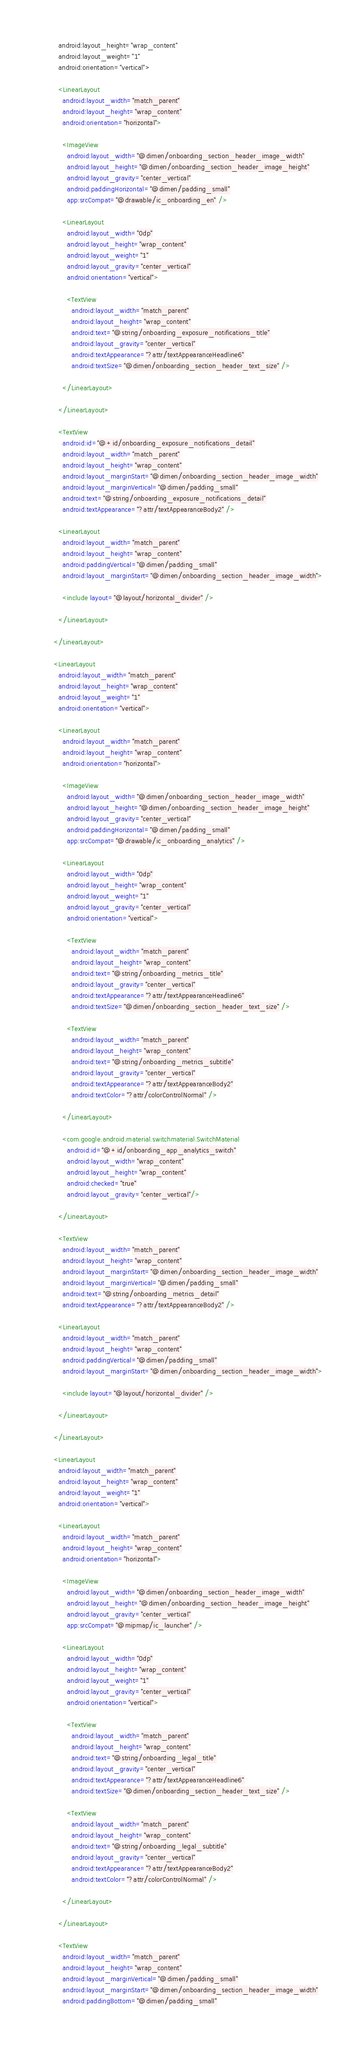Convert code to text. <code><loc_0><loc_0><loc_500><loc_500><_XML_>        android:layout_height="wrap_content"
        android:layout_weight="1"
        android:orientation="vertical">

        <LinearLayout
          android:layout_width="match_parent"
          android:layout_height="wrap_content"
          android:orientation="horizontal">

          <ImageView
            android:layout_width="@dimen/onboarding_section_header_image_width"
            android:layout_height="@dimen/onboarding_section_header_image_height"
            android:layout_gravity="center_vertical"
            android:paddingHorizontal="@dimen/padding_small"
            app:srcCompat="@drawable/ic_onboarding_en" />

          <LinearLayout
            android:layout_width="0dp"
            android:layout_height="wrap_content"
            android:layout_weight="1"
            android:layout_gravity="center_vertical"
            android:orientation="vertical">

            <TextView
              android:layout_width="match_parent"
              android:layout_height="wrap_content"
              android:text="@string/onboarding_exposure_notifications_title"
              android:layout_gravity="center_vertical"
              android:textAppearance="?attr/textAppearanceHeadline6"
              android:textSize="@dimen/onboarding_section_header_text_size" />

          </LinearLayout>

        </LinearLayout>

        <TextView
          android:id="@+id/onboarding_exposure_notifications_detail"
          android:layout_width="match_parent"
          android:layout_height="wrap_content"
          android:layout_marginStart="@dimen/onboarding_section_header_image_width"
          android:layout_marginVertical="@dimen/padding_small"
          android:text="@string/onboarding_exposure_notifications_detail"
          android:textAppearance="?attr/textAppearanceBody2" />

        <LinearLayout
          android:layout_width="match_parent"
          android:layout_height="wrap_content"
          android:paddingVertical="@dimen/padding_small"
          android:layout_marginStart="@dimen/onboarding_section_header_image_width">

          <include layout="@layout/horizontal_divider" />

        </LinearLayout>

      </LinearLayout>

      <LinearLayout
        android:layout_width="match_parent"
        android:layout_height="wrap_content"
        android:layout_weight="1"
        android:orientation="vertical">

        <LinearLayout
          android:layout_width="match_parent"
          android:layout_height="wrap_content"
          android:orientation="horizontal">

          <ImageView
            android:layout_width="@dimen/onboarding_section_header_image_width"
            android:layout_height="@dimen/onboarding_section_header_image_height"
            android:layout_gravity="center_vertical"
            android:paddingHorizontal="@dimen/padding_small"
            app:srcCompat="@drawable/ic_onboarding_analytics" />

          <LinearLayout
            android:layout_width="0dp"
            android:layout_height="wrap_content"
            android:layout_weight="1"
            android:layout_gravity="center_vertical"
            android:orientation="vertical">

            <TextView
              android:layout_width="match_parent"
              android:layout_height="wrap_content"
              android:text="@string/onboarding_metrics_title"
              android:layout_gravity="center_vertical"
              android:textAppearance="?attr/textAppearanceHeadline6"
              android:textSize="@dimen/onboarding_section_header_text_size" />

            <TextView
              android:layout_width="match_parent"
              android:layout_height="wrap_content"
              android:text="@string/onboarding_metrics_subtitle"
              android:layout_gravity="center_vertical"
              android:textAppearance="?attr/textAppearanceBody2"
              android:textColor="?attr/colorControlNormal" />

          </LinearLayout>

          <com.google.android.material.switchmaterial.SwitchMaterial
            android:id="@+id/onboarding_app_analytics_switch"
            android:layout_width="wrap_content"
            android:layout_height="wrap_content"
            android:checked="true"
            android:layout_gravity="center_vertical"/>

        </LinearLayout>

        <TextView
          android:layout_width="match_parent"
          android:layout_height="wrap_content"
          android:layout_marginStart="@dimen/onboarding_section_header_image_width"
          android:layout_marginVertical="@dimen/padding_small"
          android:text="@string/onboarding_metrics_detail"
          android:textAppearance="?attr/textAppearanceBody2" />

        <LinearLayout
          android:layout_width="match_parent"
          android:layout_height="wrap_content"
          android:paddingVertical="@dimen/padding_small"
          android:layout_marginStart="@dimen/onboarding_section_header_image_width">

          <include layout="@layout/horizontal_divider" />

        </LinearLayout>

      </LinearLayout>

      <LinearLayout
        android:layout_width="match_parent"
        android:layout_height="wrap_content"
        android:layout_weight="1"
        android:orientation="vertical">

        <LinearLayout
          android:layout_width="match_parent"
          android:layout_height="wrap_content"
          android:orientation="horizontal">

          <ImageView
            android:layout_width="@dimen/onboarding_section_header_image_width"
            android:layout_height="@dimen/onboarding_section_header_image_height"
            android:layout_gravity="center_vertical"
            app:srcCompat="@mipmap/ic_launcher" />

          <LinearLayout
            android:layout_width="0dp"
            android:layout_height="wrap_content"
            android:layout_weight="1"
            android:layout_gravity="center_vertical"
            android:orientation="vertical">

            <TextView
              android:layout_width="match_parent"
              android:layout_height="wrap_content"
              android:text="@string/onboarding_legal_title"
              android:layout_gravity="center_vertical"
              android:textAppearance="?attr/textAppearanceHeadline6"
              android:textSize="@dimen/onboarding_section_header_text_size" />

            <TextView
              android:layout_width="match_parent"
              android:layout_height="wrap_content"
              android:text="@string/onboarding_legal_subtitle"
              android:layout_gravity="center_vertical"
              android:textAppearance="?attr/textAppearanceBody2"
              android:textColor="?attr/colorControlNormal" />

          </LinearLayout>

        </LinearLayout>

        <TextView
          android:layout_width="match_parent"
          android:layout_height="wrap_content"
          android:layout_marginVertical="@dimen/padding_small"
          android:layout_marginStart="@dimen/onboarding_section_header_image_width"
          android:paddingBottom="@dimen/padding_small"</code> 